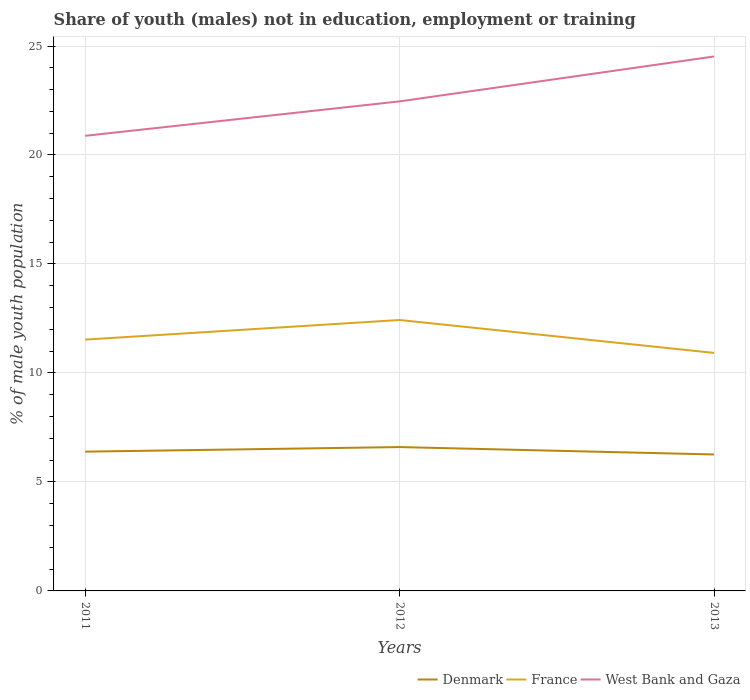Does the line corresponding to Denmark intersect with the line corresponding to France?
Your answer should be very brief. No. Is the number of lines equal to the number of legend labels?
Your answer should be compact. Yes. Across all years, what is the maximum percentage of unemployed males population in in France?
Give a very brief answer. 10.92. In which year was the percentage of unemployed males population in in Denmark maximum?
Make the answer very short. 2013. What is the total percentage of unemployed males population in in France in the graph?
Provide a short and direct response. 1.51. What is the difference between the highest and the second highest percentage of unemployed males population in in West Bank and Gaza?
Give a very brief answer. 3.64. What is the difference between the highest and the lowest percentage of unemployed males population in in Denmark?
Make the answer very short. 1. Is the percentage of unemployed males population in in West Bank and Gaza strictly greater than the percentage of unemployed males population in in France over the years?
Your answer should be compact. No. How many years are there in the graph?
Offer a terse response. 3. Does the graph contain any zero values?
Your answer should be very brief. No. Where does the legend appear in the graph?
Your response must be concise. Bottom right. How are the legend labels stacked?
Provide a succinct answer. Horizontal. What is the title of the graph?
Your answer should be compact. Share of youth (males) not in education, employment or training. What is the label or title of the X-axis?
Your answer should be very brief. Years. What is the label or title of the Y-axis?
Provide a short and direct response. % of male youth population. What is the % of male youth population in Denmark in 2011?
Your answer should be compact. 6.39. What is the % of male youth population in France in 2011?
Your response must be concise. 11.53. What is the % of male youth population of West Bank and Gaza in 2011?
Make the answer very short. 20.88. What is the % of male youth population of Denmark in 2012?
Offer a terse response. 6.6. What is the % of male youth population in France in 2012?
Provide a short and direct response. 12.43. What is the % of male youth population in West Bank and Gaza in 2012?
Your answer should be very brief. 22.46. What is the % of male youth population in Denmark in 2013?
Ensure brevity in your answer.  6.26. What is the % of male youth population in France in 2013?
Keep it short and to the point. 10.92. What is the % of male youth population in West Bank and Gaza in 2013?
Your response must be concise. 24.52. Across all years, what is the maximum % of male youth population of Denmark?
Offer a terse response. 6.6. Across all years, what is the maximum % of male youth population of France?
Provide a short and direct response. 12.43. Across all years, what is the maximum % of male youth population of West Bank and Gaza?
Your answer should be compact. 24.52. Across all years, what is the minimum % of male youth population in Denmark?
Offer a terse response. 6.26. Across all years, what is the minimum % of male youth population of France?
Your answer should be very brief. 10.92. Across all years, what is the minimum % of male youth population in West Bank and Gaza?
Keep it short and to the point. 20.88. What is the total % of male youth population of Denmark in the graph?
Offer a terse response. 19.25. What is the total % of male youth population of France in the graph?
Keep it short and to the point. 34.88. What is the total % of male youth population in West Bank and Gaza in the graph?
Provide a short and direct response. 67.86. What is the difference between the % of male youth population in Denmark in 2011 and that in 2012?
Your response must be concise. -0.21. What is the difference between the % of male youth population in West Bank and Gaza in 2011 and that in 2012?
Give a very brief answer. -1.58. What is the difference between the % of male youth population of Denmark in 2011 and that in 2013?
Keep it short and to the point. 0.13. What is the difference between the % of male youth population in France in 2011 and that in 2013?
Offer a very short reply. 0.61. What is the difference between the % of male youth population of West Bank and Gaza in 2011 and that in 2013?
Ensure brevity in your answer.  -3.64. What is the difference between the % of male youth population of Denmark in 2012 and that in 2013?
Your answer should be very brief. 0.34. What is the difference between the % of male youth population in France in 2012 and that in 2013?
Make the answer very short. 1.51. What is the difference between the % of male youth population of West Bank and Gaza in 2012 and that in 2013?
Your answer should be very brief. -2.06. What is the difference between the % of male youth population of Denmark in 2011 and the % of male youth population of France in 2012?
Provide a succinct answer. -6.04. What is the difference between the % of male youth population of Denmark in 2011 and the % of male youth population of West Bank and Gaza in 2012?
Your answer should be compact. -16.07. What is the difference between the % of male youth population in France in 2011 and the % of male youth population in West Bank and Gaza in 2012?
Provide a succinct answer. -10.93. What is the difference between the % of male youth population of Denmark in 2011 and the % of male youth population of France in 2013?
Offer a terse response. -4.53. What is the difference between the % of male youth population of Denmark in 2011 and the % of male youth population of West Bank and Gaza in 2013?
Offer a very short reply. -18.13. What is the difference between the % of male youth population of France in 2011 and the % of male youth population of West Bank and Gaza in 2013?
Keep it short and to the point. -12.99. What is the difference between the % of male youth population in Denmark in 2012 and the % of male youth population in France in 2013?
Offer a very short reply. -4.32. What is the difference between the % of male youth population in Denmark in 2012 and the % of male youth population in West Bank and Gaza in 2013?
Offer a very short reply. -17.92. What is the difference between the % of male youth population in France in 2012 and the % of male youth population in West Bank and Gaza in 2013?
Offer a very short reply. -12.09. What is the average % of male youth population of Denmark per year?
Offer a very short reply. 6.42. What is the average % of male youth population of France per year?
Offer a very short reply. 11.63. What is the average % of male youth population in West Bank and Gaza per year?
Provide a short and direct response. 22.62. In the year 2011, what is the difference between the % of male youth population of Denmark and % of male youth population of France?
Offer a terse response. -5.14. In the year 2011, what is the difference between the % of male youth population in Denmark and % of male youth population in West Bank and Gaza?
Provide a short and direct response. -14.49. In the year 2011, what is the difference between the % of male youth population in France and % of male youth population in West Bank and Gaza?
Provide a short and direct response. -9.35. In the year 2012, what is the difference between the % of male youth population of Denmark and % of male youth population of France?
Provide a short and direct response. -5.83. In the year 2012, what is the difference between the % of male youth population in Denmark and % of male youth population in West Bank and Gaza?
Give a very brief answer. -15.86. In the year 2012, what is the difference between the % of male youth population in France and % of male youth population in West Bank and Gaza?
Offer a terse response. -10.03. In the year 2013, what is the difference between the % of male youth population of Denmark and % of male youth population of France?
Offer a terse response. -4.66. In the year 2013, what is the difference between the % of male youth population in Denmark and % of male youth population in West Bank and Gaza?
Offer a very short reply. -18.26. In the year 2013, what is the difference between the % of male youth population in France and % of male youth population in West Bank and Gaza?
Make the answer very short. -13.6. What is the ratio of the % of male youth population in Denmark in 2011 to that in 2012?
Give a very brief answer. 0.97. What is the ratio of the % of male youth population in France in 2011 to that in 2012?
Your answer should be compact. 0.93. What is the ratio of the % of male youth population in West Bank and Gaza in 2011 to that in 2012?
Your answer should be compact. 0.93. What is the ratio of the % of male youth population of Denmark in 2011 to that in 2013?
Keep it short and to the point. 1.02. What is the ratio of the % of male youth population of France in 2011 to that in 2013?
Offer a terse response. 1.06. What is the ratio of the % of male youth population of West Bank and Gaza in 2011 to that in 2013?
Keep it short and to the point. 0.85. What is the ratio of the % of male youth population of Denmark in 2012 to that in 2013?
Your answer should be compact. 1.05. What is the ratio of the % of male youth population in France in 2012 to that in 2013?
Provide a succinct answer. 1.14. What is the ratio of the % of male youth population of West Bank and Gaza in 2012 to that in 2013?
Make the answer very short. 0.92. What is the difference between the highest and the second highest % of male youth population in Denmark?
Make the answer very short. 0.21. What is the difference between the highest and the second highest % of male youth population in West Bank and Gaza?
Provide a short and direct response. 2.06. What is the difference between the highest and the lowest % of male youth population of Denmark?
Your answer should be very brief. 0.34. What is the difference between the highest and the lowest % of male youth population in France?
Ensure brevity in your answer.  1.51. What is the difference between the highest and the lowest % of male youth population in West Bank and Gaza?
Your answer should be compact. 3.64. 